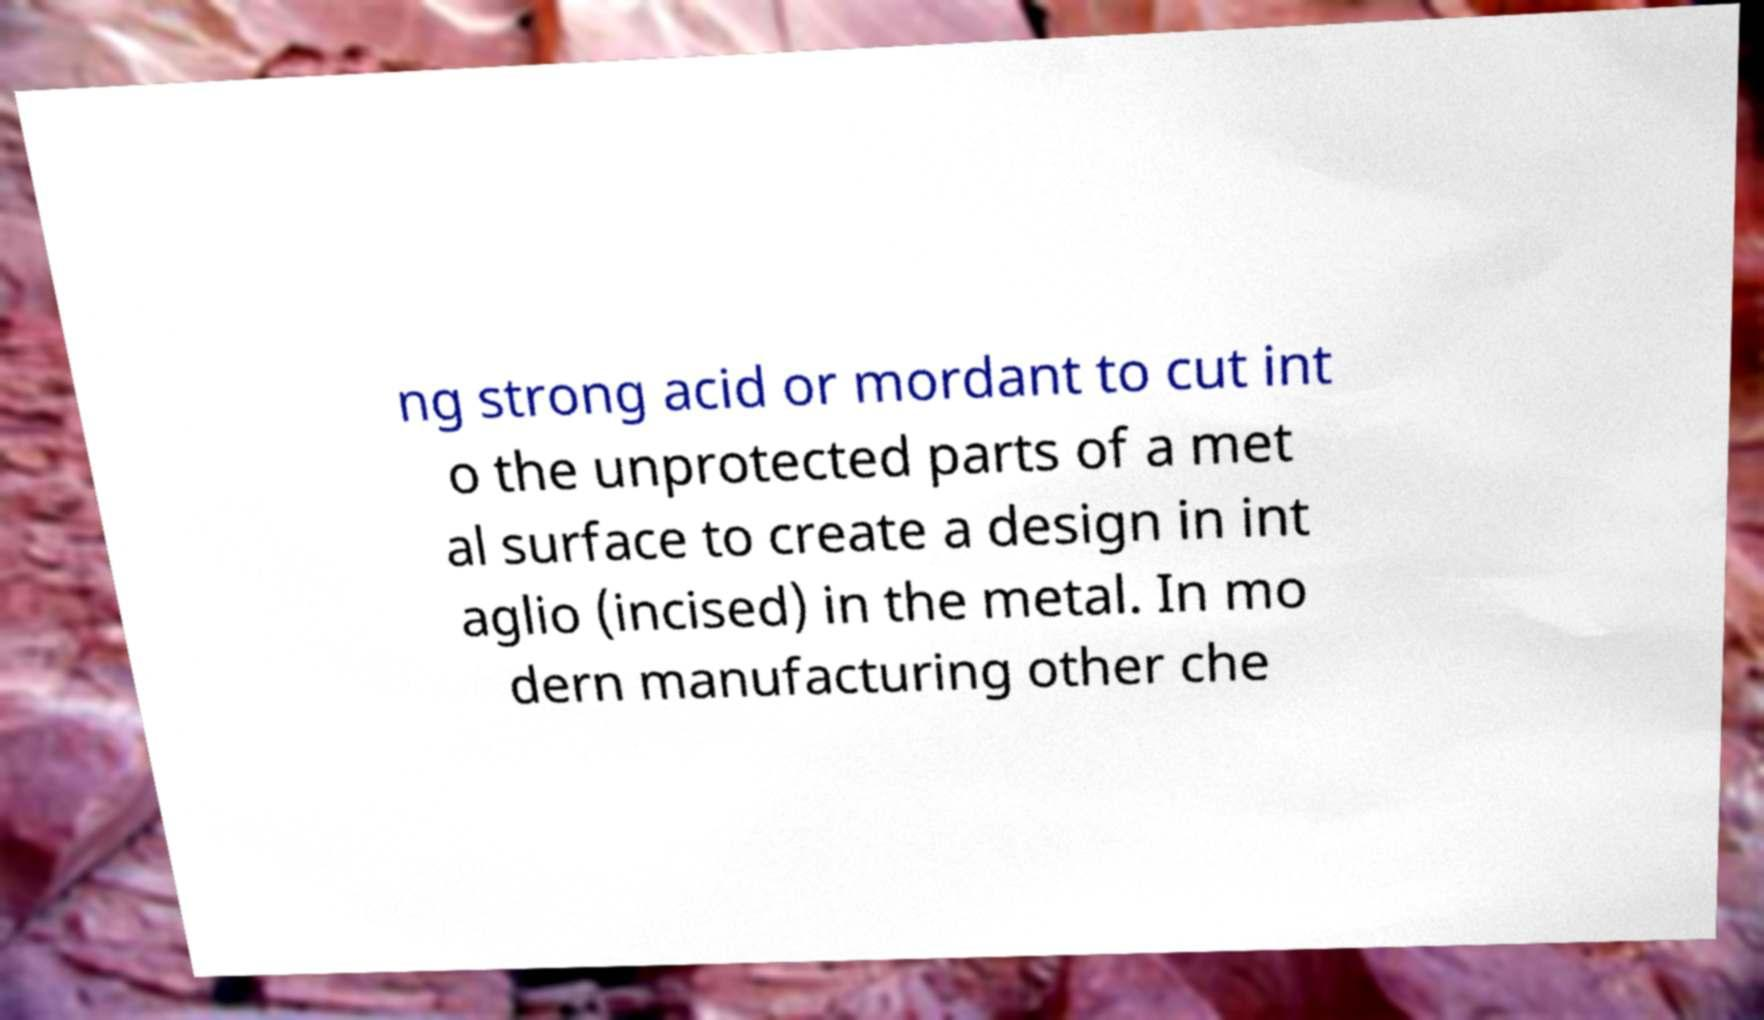Please read and relay the text visible in this image. What does it say? ng strong acid or mordant to cut int o the unprotected parts of a met al surface to create a design in int aglio (incised) in the metal. In mo dern manufacturing other che 